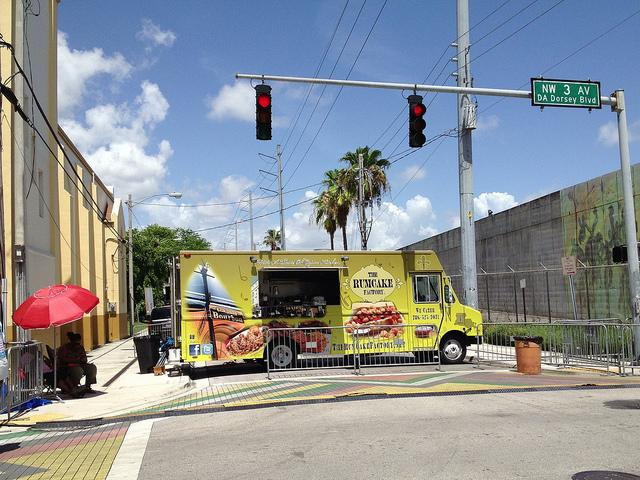What is the yellow truck doing? Please explain your reasoning. selling food. The yellow vehicle is a food truck and sells things to eat. 